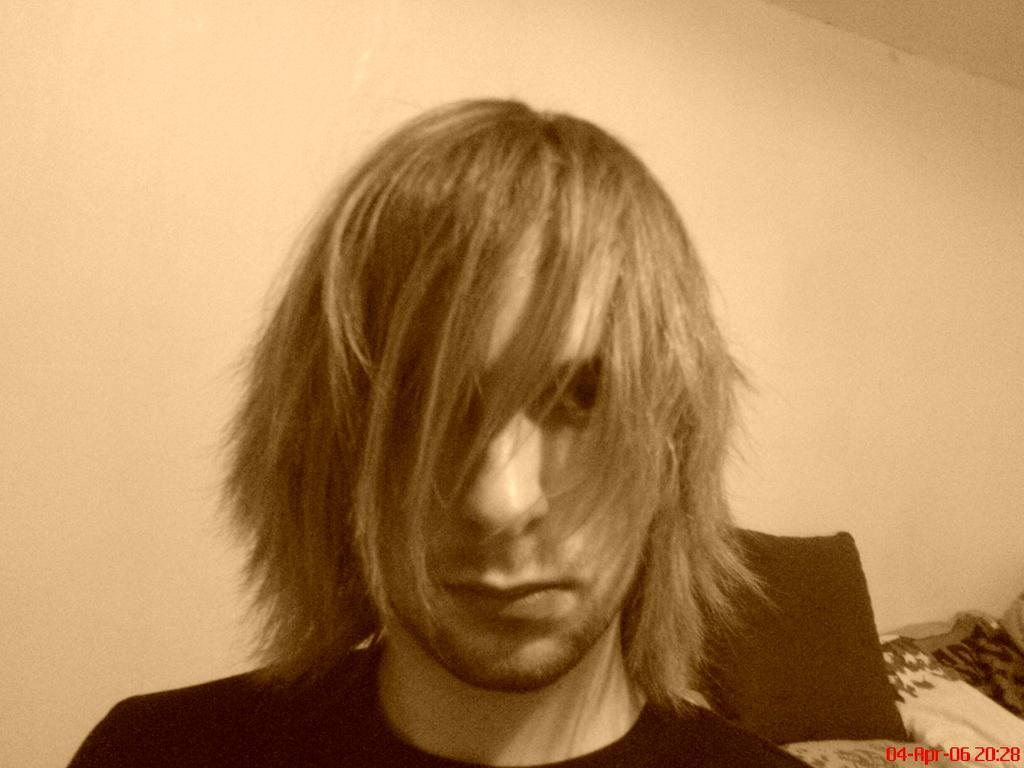Who or what is present in the image? There is a person in the image. What object can be seen near the person? There is a pillow in the image. What else is visible in the image besides the person and pillow? There are clothes and a wall in the image. Is there any indication that the image has been reproduced or shared? Yes, there is a watermark on the image. What theory is being proposed by the person in the image? There is no indication of a theory being proposed in the image; it simply shows a person with a pillow and clothes near a wall. How many cents are visible in the image? There are no cents present in the image. 